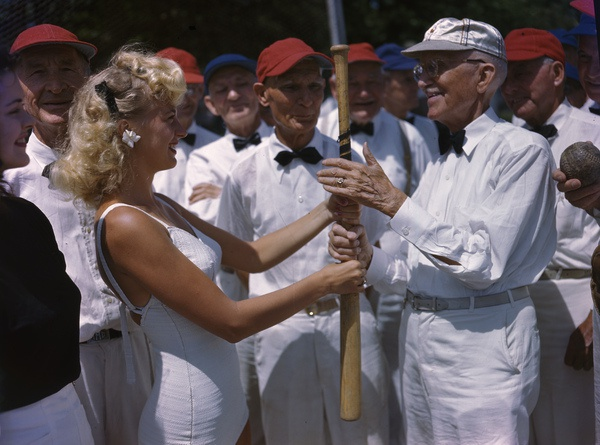Describe the objects in this image and their specific colors. I can see people in black, darkgray, gray, and lightgray tones, people in black, gray, maroon, brown, and darkgray tones, people in black, gray, darkgray, and lightgray tones, people in black, gray, darkgray, and maroon tones, and people in black, gray, and purple tones in this image. 